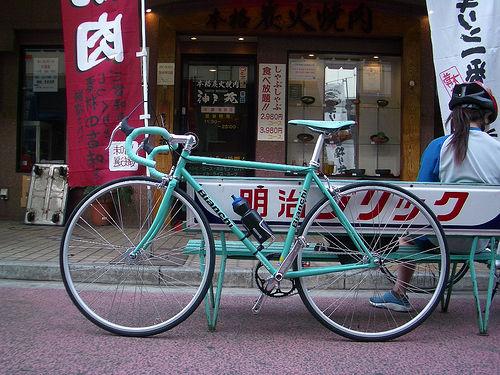What does the sign say the bike is leaning on?
Short answer required. Bench. Does the bike belong to the person sitting on the bench?
Keep it brief. Yes. What color is the bike?
Keep it brief. Teal. 